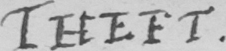What does this handwritten line say? THEFT 